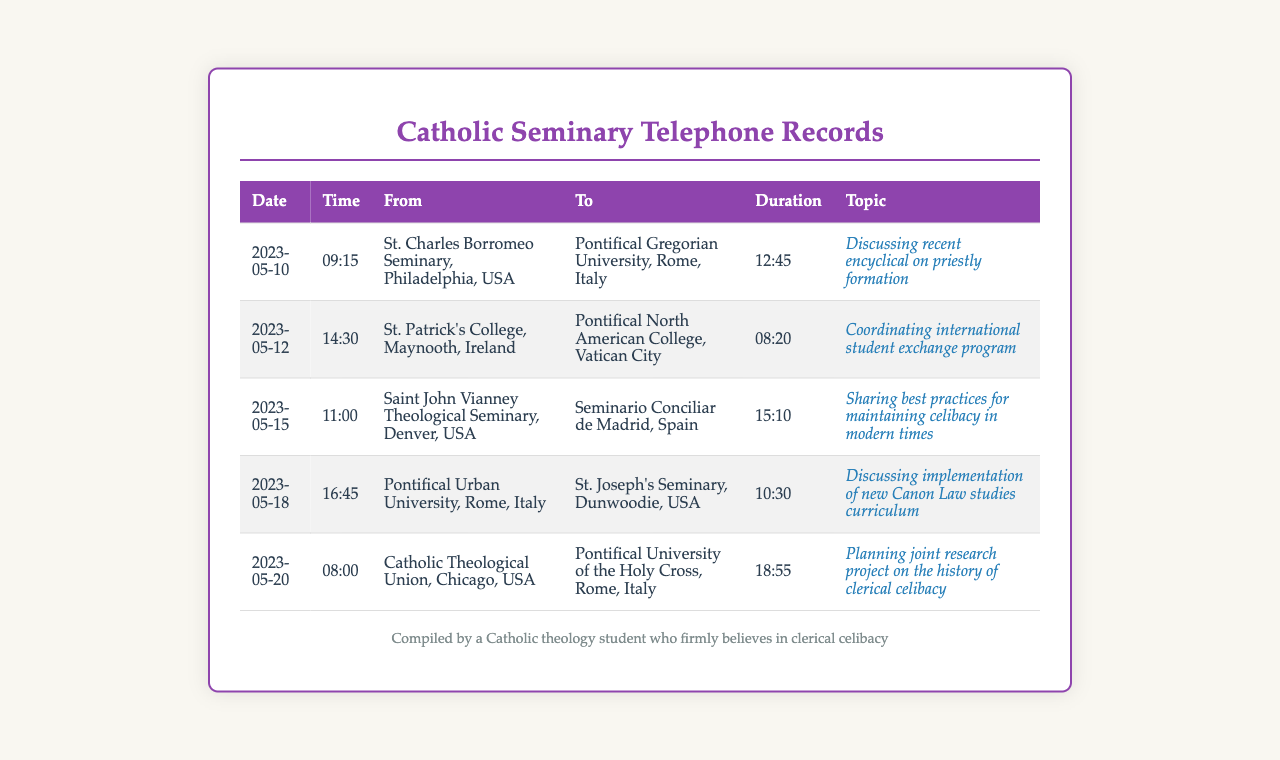What is the date of the call from St. Patrick's College? The date of the call from St. Patrick's College is listed in the records under the respective entry.
Answer: 2023-05-12 What was the duration of the call from Catholic Theological Union? The duration can be found in the corresponding row under the duration column.
Answer: 18:55 Which seminary was involved in the call regarding the encyclical on priestly formation? This seminary can be identified from the details provided in the specific call entry.
Answer: St. Charles Borromeo Seminary, Philadelphia, USA How many calls were made from seminaries in the United States? This can be calculated by counting the rows where the "From" column lists seminaries located in the United States.
Answer: 3 What topic was discussed during the call on May 15? The topic can be found in the same row as the date specified, under the topic column.
Answer: Sharing best practices for maintaining celibacy in modern times Which seminary was involved in the call about the history of clerical celibacy? This can be inferred by identifying the relevant call entry about the research project.
Answer: Catholic Theological Union, Chicago, USA What is the total number of calls listed in this document? The total number can be found by counting the entries in the table.
Answer: 5 What time was the call between Pontifical Urban University and St. Joseph's Seminary? The time can be found in the specific record related to this call.
Answer: 16:45 